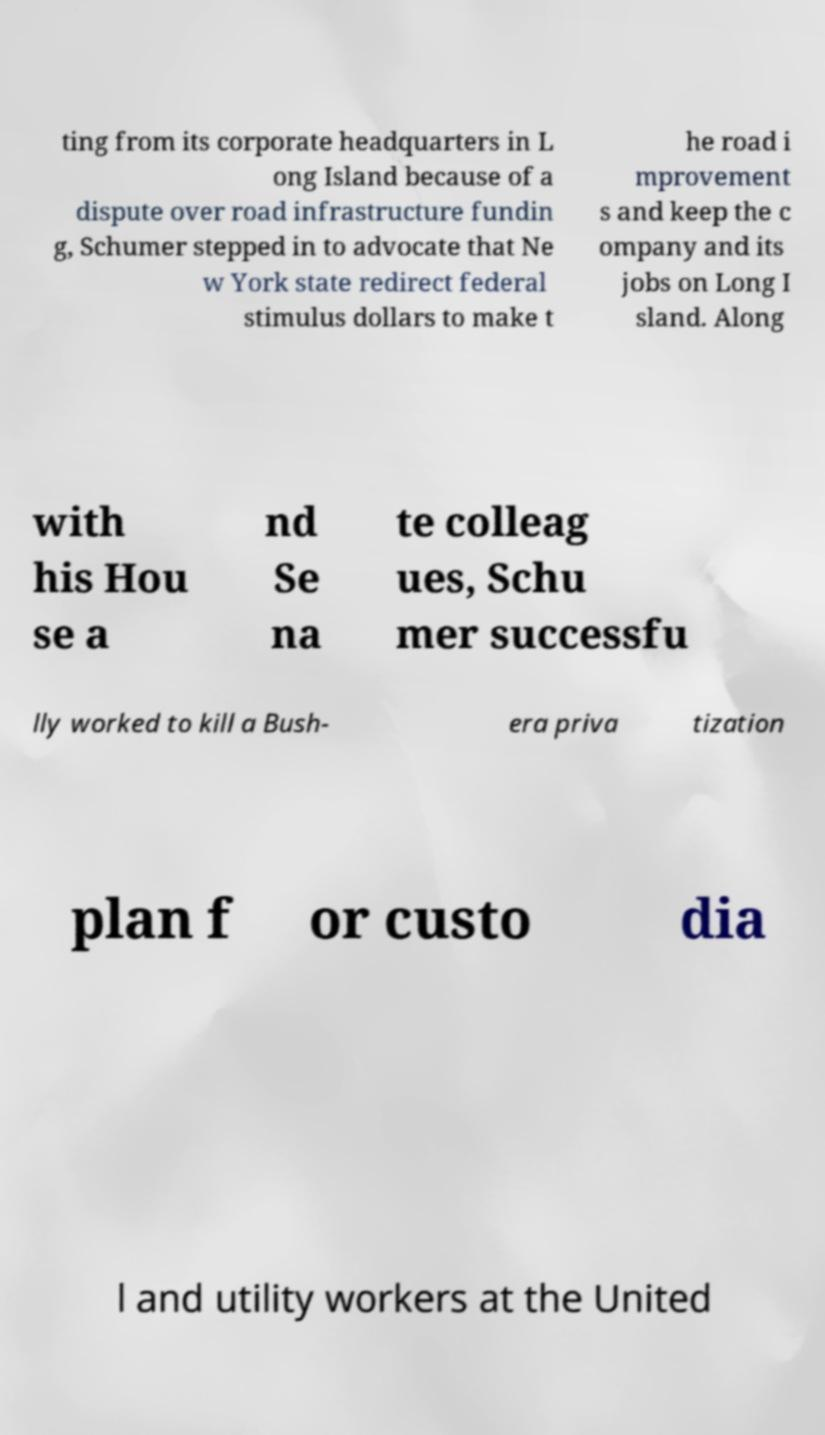Please read and relay the text visible in this image. What does it say? ting from its corporate headquarters in L ong Island because of a dispute over road infrastructure fundin g, Schumer stepped in to advocate that Ne w York state redirect federal stimulus dollars to make t he road i mprovement s and keep the c ompany and its jobs on Long I sland. Along with his Hou se a nd Se na te colleag ues, Schu mer successfu lly worked to kill a Bush- era priva tization plan f or custo dia l and utility workers at the United 